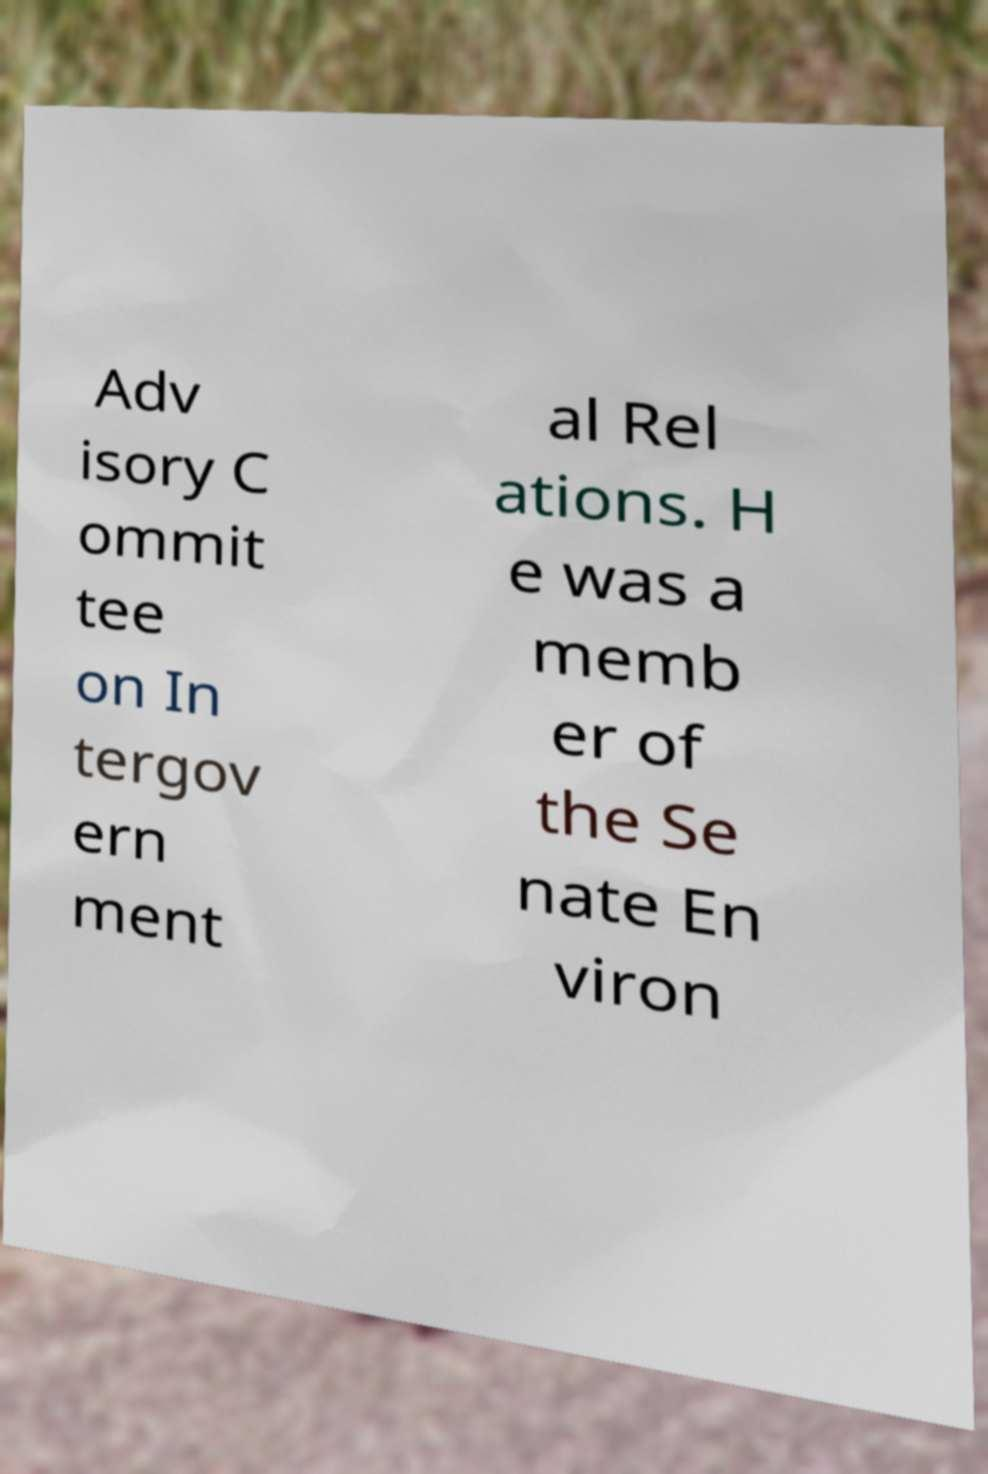Please read and relay the text visible in this image. What does it say? Adv isory C ommit tee on In tergov ern ment al Rel ations. H e was a memb er of the Se nate En viron 